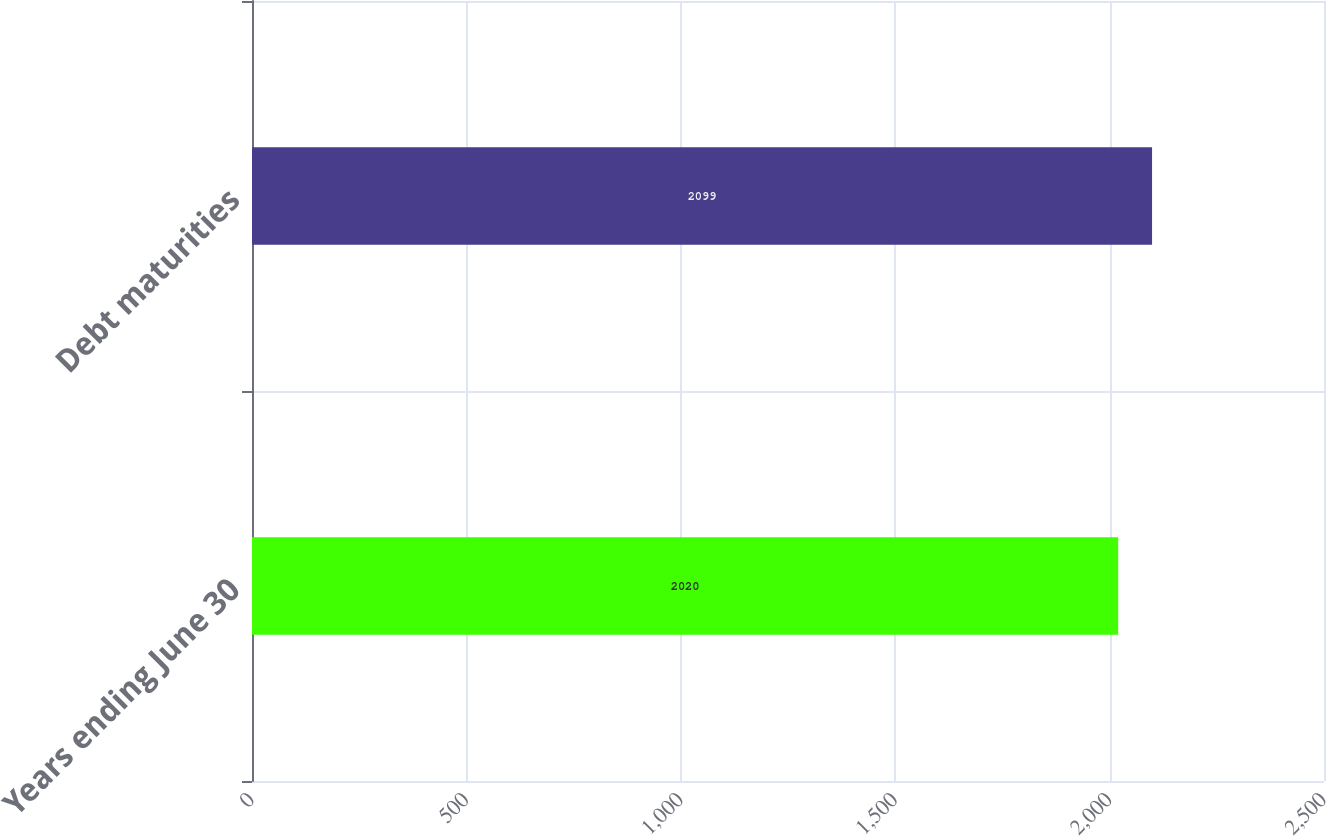Convert chart to OTSL. <chart><loc_0><loc_0><loc_500><loc_500><bar_chart><fcel>Years ending June 30<fcel>Debt maturities<nl><fcel>2020<fcel>2099<nl></chart> 